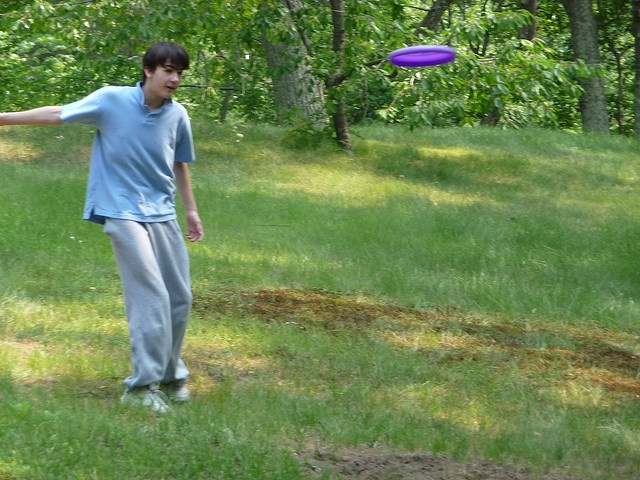Describe the objects in this image and their specific colors. I can see people in darkgreen, gray, and darkgray tones and frisbee in darkgreen, magenta, darkblue, and blue tones in this image. 